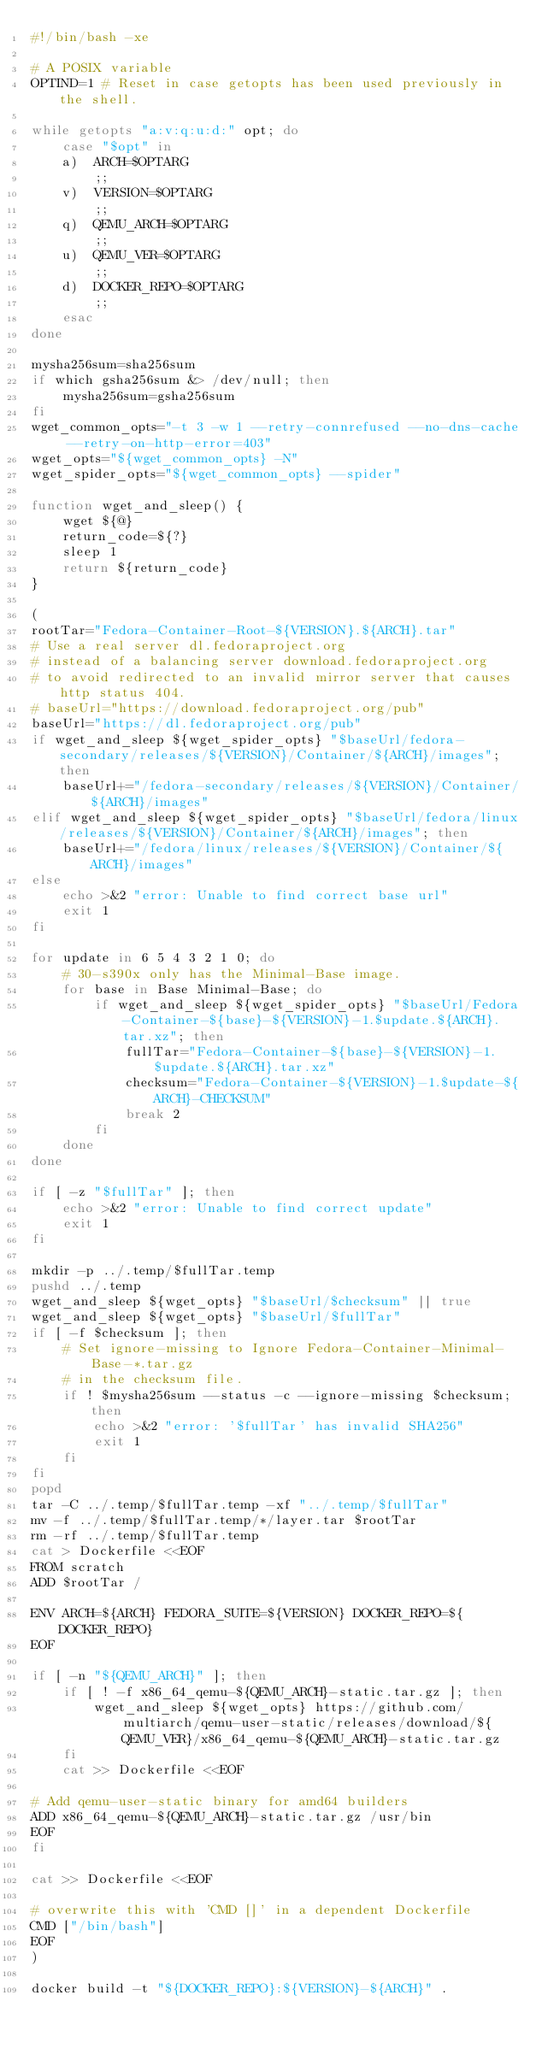<code> <loc_0><loc_0><loc_500><loc_500><_Bash_>#!/bin/bash -xe

# A POSIX variable
OPTIND=1 # Reset in case getopts has been used previously in the shell.

while getopts "a:v:q:u:d:" opt; do
    case "$opt" in
    a)  ARCH=$OPTARG
        ;;
    v)  VERSION=$OPTARG
        ;;
    q)  QEMU_ARCH=$OPTARG
        ;;
    u)  QEMU_VER=$OPTARG
        ;;
    d)  DOCKER_REPO=$OPTARG
        ;;
    esac
done

mysha256sum=sha256sum
if which gsha256sum &> /dev/null; then
    mysha256sum=gsha256sum
fi
wget_common_opts="-t 3 -w 1 --retry-connrefused --no-dns-cache --retry-on-http-error=403"
wget_opts="${wget_common_opts} -N"
wget_spider_opts="${wget_common_opts} --spider"

function wget_and_sleep() {
    wget ${@}
    return_code=${?}
    sleep 1
    return ${return_code}
}

(
rootTar="Fedora-Container-Root-${VERSION}.${ARCH}.tar"
# Use a real server dl.fedoraproject.org
# instead of a balancing server download.fedoraproject.org
# to avoid redirected to an invalid mirror server that causes http status 404.
# baseUrl="https://download.fedoraproject.org/pub"
baseUrl="https://dl.fedoraproject.org/pub"
if wget_and_sleep ${wget_spider_opts} "$baseUrl/fedora-secondary/releases/${VERSION}/Container/${ARCH}/images"; then
    baseUrl+="/fedora-secondary/releases/${VERSION}/Container/${ARCH}/images"
elif wget_and_sleep ${wget_spider_opts} "$baseUrl/fedora/linux/releases/${VERSION}/Container/${ARCH}/images"; then
    baseUrl+="/fedora/linux/releases/${VERSION}/Container/${ARCH}/images"
else
    echo >&2 "error: Unable to find correct base url"
    exit 1
fi

for update in 6 5 4 3 2 1 0; do
    # 30-s390x only has the Minimal-Base image.
    for base in Base Minimal-Base; do
        if wget_and_sleep ${wget_spider_opts} "$baseUrl/Fedora-Container-${base}-${VERSION}-1.$update.${ARCH}.tar.xz"; then
            fullTar="Fedora-Container-${base}-${VERSION}-1.$update.${ARCH}.tar.xz"
            checksum="Fedora-Container-${VERSION}-1.$update-${ARCH}-CHECKSUM"
            break 2
        fi
    done
done

if [ -z "$fullTar" ]; then
    echo >&2 "error: Unable to find correct update"
    exit 1
fi

mkdir -p ../.temp/$fullTar.temp
pushd ../.temp
wget_and_sleep ${wget_opts} "$baseUrl/$checksum" || true
wget_and_sleep ${wget_opts} "$baseUrl/$fullTar"
if [ -f $checksum ]; then
    # Set ignore-missing to Ignore Fedora-Container-Minimal-Base-*.tar.gz
    # in the checksum file.
    if ! $mysha256sum --status -c --ignore-missing $checksum; then
        echo >&2 "error: '$fullTar' has invalid SHA256"
        exit 1
    fi
fi
popd
tar -C ../.temp/$fullTar.temp -xf "../.temp/$fullTar"
mv -f ../.temp/$fullTar.temp/*/layer.tar $rootTar
rm -rf ../.temp/$fullTar.temp
cat > Dockerfile <<EOF
FROM scratch
ADD $rootTar /

ENV ARCH=${ARCH} FEDORA_SUITE=${VERSION} DOCKER_REPO=${DOCKER_REPO}
EOF

if [ -n "${QEMU_ARCH}" ]; then
    if [ ! -f x86_64_qemu-${QEMU_ARCH}-static.tar.gz ]; then
        wget_and_sleep ${wget_opts} https://github.com/multiarch/qemu-user-static/releases/download/${QEMU_VER}/x86_64_qemu-${QEMU_ARCH}-static.tar.gz
    fi
    cat >> Dockerfile <<EOF

# Add qemu-user-static binary for amd64 builders
ADD x86_64_qemu-${QEMU_ARCH}-static.tar.gz /usr/bin
EOF
fi

cat >> Dockerfile <<EOF

# overwrite this with 'CMD []' in a dependent Dockerfile
CMD ["/bin/bash"]
EOF
)

docker build -t "${DOCKER_REPO}:${VERSION}-${ARCH}" .</code> 